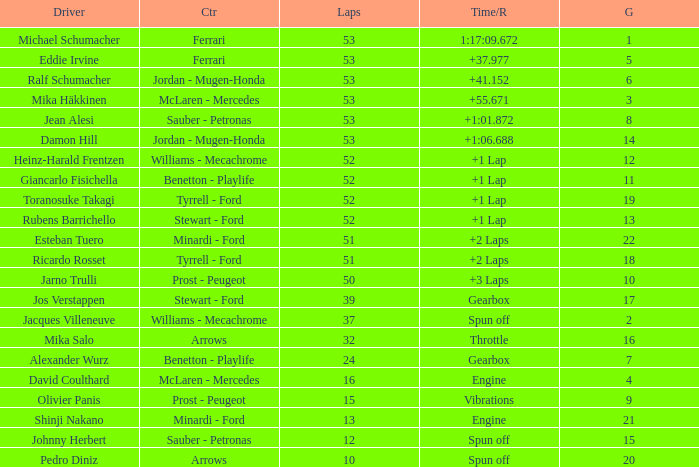Who built the car that went 53 laps with a Time/Retired of 1:17:09.672? Ferrari. 